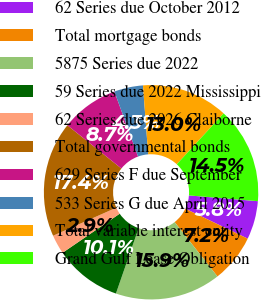Convert chart to OTSL. <chart><loc_0><loc_0><loc_500><loc_500><pie_chart><fcel>62 Series due October 2012<fcel>Total mortgage bonds<fcel>5875 Series due 2022<fcel>59 Series due 2022 Mississippi<fcel>62 Series due 2026 Claiborne<fcel>Total governmental bonds<fcel>629 Series F due September<fcel>533 Series G due April 2015<fcel>Total variable interest entity<fcel>Grand Gulf Lease Obligation<nl><fcel>5.8%<fcel>7.25%<fcel>15.94%<fcel>10.14%<fcel>2.9%<fcel>17.39%<fcel>8.7%<fcel>4.35%<fcel>13.04%<fcel>14.49%<nl></chart> 